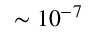<formula> <loc_0><loc_0><loc_500><loc_500>\sim 1 0 ^ { - 7 }</formula> 